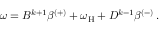<formula> <loc_0><loc_0><loc_500><loc_500>\begin{array} { r } { \omega = B ^ { k + 1 } \beta ^ { ( + ) } + \omega _ { H } + D ^ { k - 1 } \beta ^ { ( - ) } \, . } \end{array}</formula> 